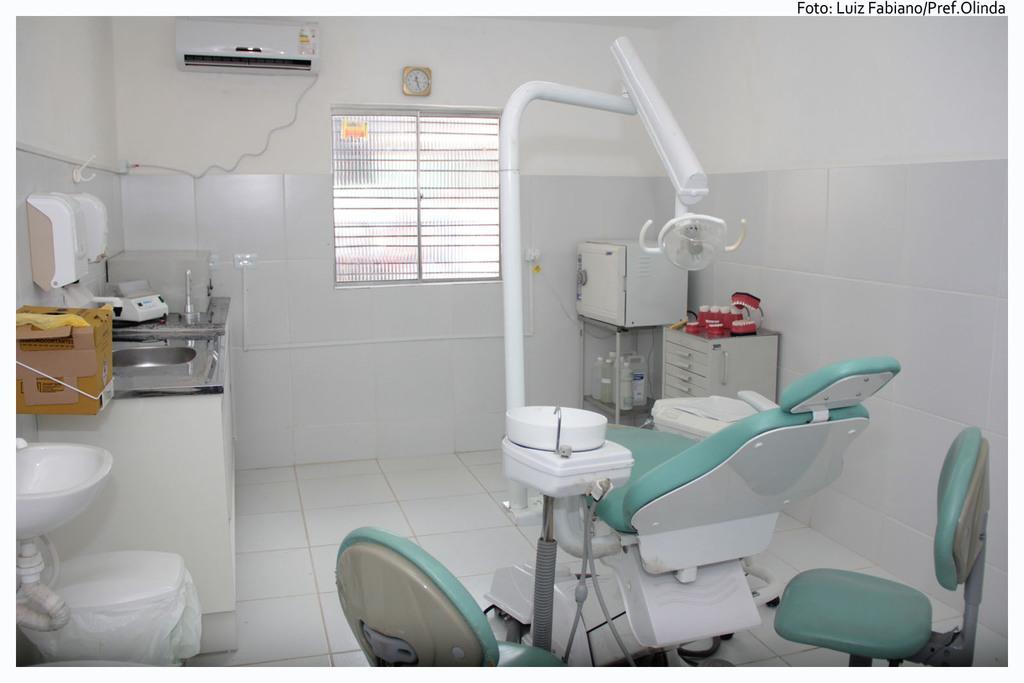How would you summarize this image in a sentence or two? In this image in the front there is an equipment which is white and green in colour. On the left side there is a wash basin and there are objects on the platform which are white in colour and brown in colour. On the the right side there are stools and on the stools there are objects which are red in colour. In the background there is a window and on the wall there is a clock and there is an AC. 